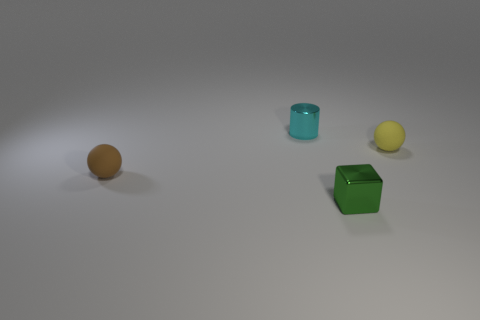Can you describe the brown object in more detail? The brown object in the image appears to be a cube with a very smooth surface and a solid brown color, suggesting it might be made of wood or a wood-like material. Its edges are sharp and precise, and it has a subtle sheen indicating it could be polished or coated. 